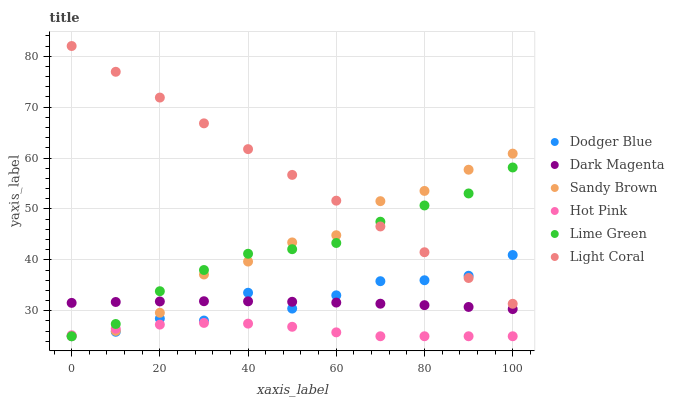Does Hot Pink have the minimum area under the curve?
Answer yes or no. Yes. Does Light Coral have the maximum area under the curve?
Answer yes or no. Yes. Does Lime Green have the minimum area under the curve?
Answer yes or no. No. Does Lime Green have the maximum area under the curve?
Answer yes or no. No. Is Light Coral the smoothest?
Answer yes or no. Yes. Is Dodger Blue the roughest?
Answer yes or no. Yes. Is Lime Green the smoothest?
Answer yes or no. No. Is Lime Green the roughest?
Answer yes or no. No. Does Lime Green have the lowest value?
Answer yes or no. Yes. Does Light Coral have the lowest value?
Answer yes or no. No. Does Light Coral have the highest value?
Answer yes or no. Yes. Does Lime Green have the highest value?
Answer yes or no. No. Is Hot Pink less than Dark Magenta?
Answer yes or no. Yes. Is Light Coral greater than Dark Magenta?
Answer yes or no. Yes. Does Lime Green intersect Light Coral?
Answer yes or no. Yes. Is Lime Green less than Light Coral?
Answer yes or no. No. Is Lime Green greater than Light Coral?
Answer yes or no. No. Does Hot Pink intersect Dark Magenta?
Answer yes or no. No. 